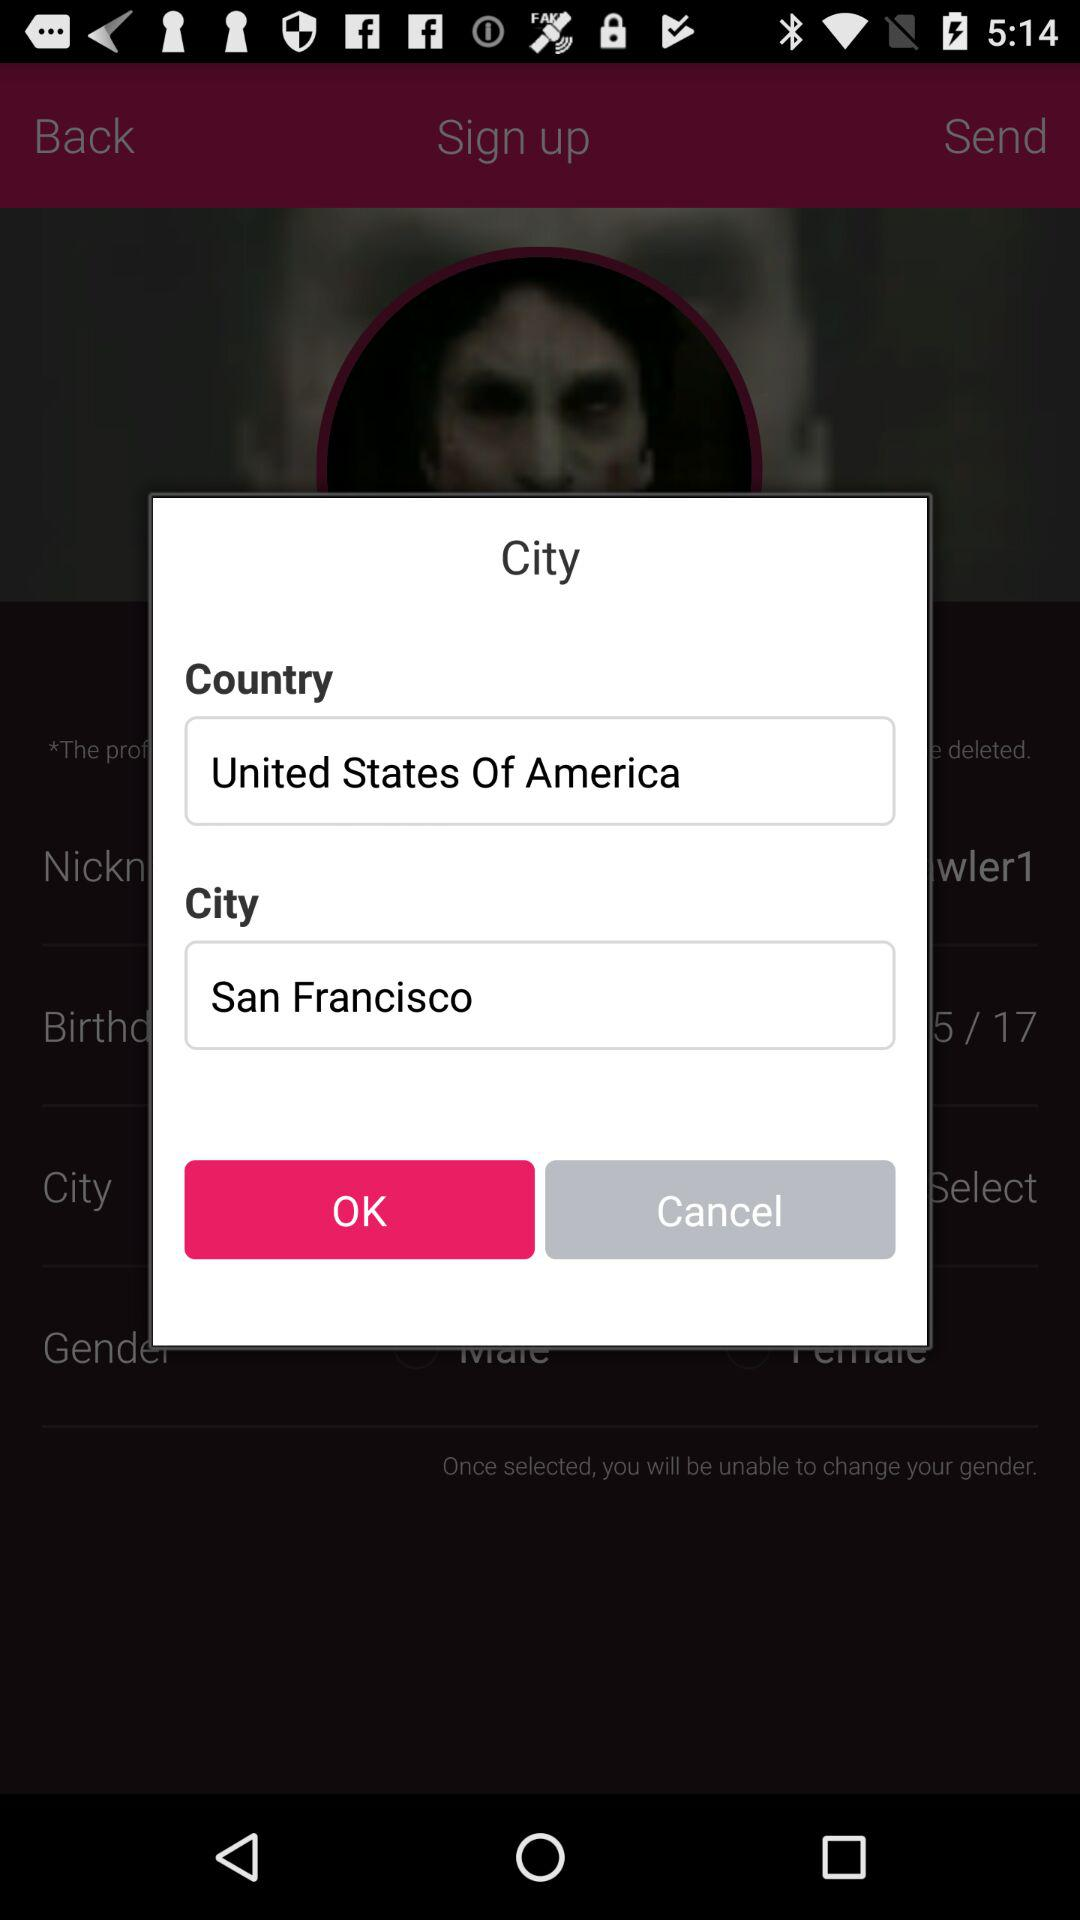What is the city name? The city name is San Francisco. 